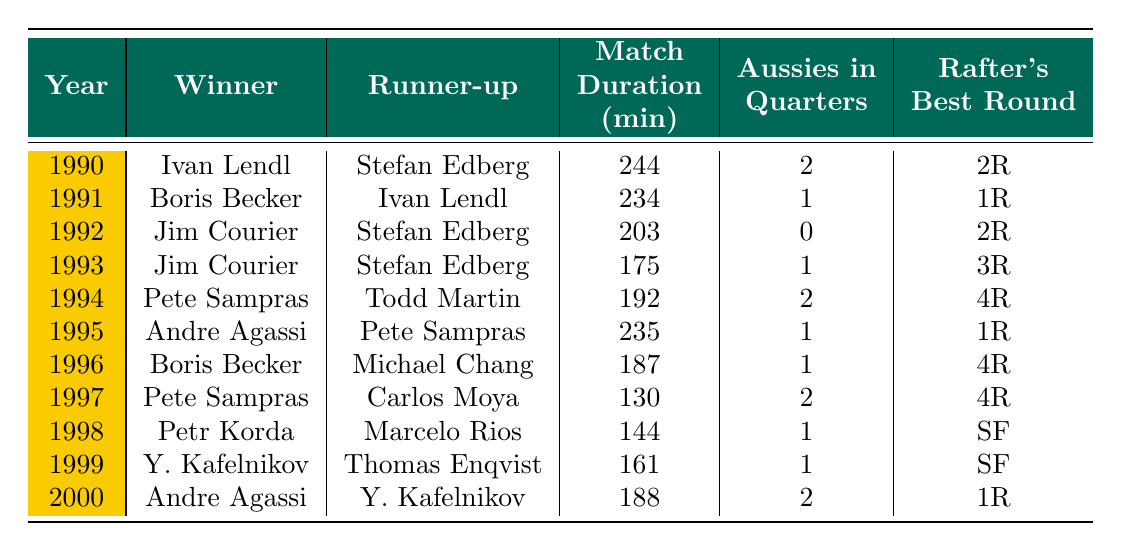What was the winner of the 1994 Australian Open men's singles final? In the table, for the year 1994, the winner is listed as Pete Sampras.
Answer: Pete Sampras Who was the runner-up in the 1999 Australian Open men's singles final? Looking at the 1999 row of the table, the runner-up is Thomas Enqvist.
Answer: Thomas Enqvist What was the match duration in minutes for the finals in 1996? According to the 1996 entry in the table, the match duration is noted as 187 minutes.
Answer: 187 minutes How many Australian players reached the quarterfinals in 1992? In the table, for the year 1992, it shows 0 Australian players reached the quarterfinals.
Answer: 0 What is the average match duration from the years 1990 to 2000? We sum the match durations: 244 + 234 + 203 + 175 + 192 + 235 + 187 + 130 + 144 + 161 + 188 = 2059. With 11 finals, the average is 2059 / 11 = 187.18, rounded gives 187.
Answer: 187 Did any Australian players reach the quarterfinals in all years listed from 1990 to 2000? By checking the "Aussies in Quarters" column for all years, only in 1990, 1994, 1997, and 2000 did 2 players reach, but in 1992 it shows 0. Therefore, the answer is no.
Answer: No In which year did Jim Courier win the Australian Open final? From the table, Jim Courier won in 1992 and 1993, as seen in those rows.
Answer: 1992 and 1993 What was the longest match duration in the finals from 1990 to 2000? By reviewing the "Match Duration" column, the longest match duration is 244 minutes in 1990.
Answer: 244 minutes How many times did Andre Agassi lose in the Australian Open finals during this period? Checking the table, Andre Agassi was a runner-up in the finals in 1995 and 2000, totaling 2 losses.
Answer: 2 What year did Patrick Rafter reach his best round of the tournament? From Patrick Rafter's best round data, his best round was the semifinals (SF) in 1998 and 1999.
Answer: 1998 and 1999 What was the difference in match duration between the finals of 1997 and 1998? The match duration in 1997 is 130 minutes and in 1998 it is 144 minutes. The difference is 144 - 130 = 14 minutes.
Answer: 14 minutes 